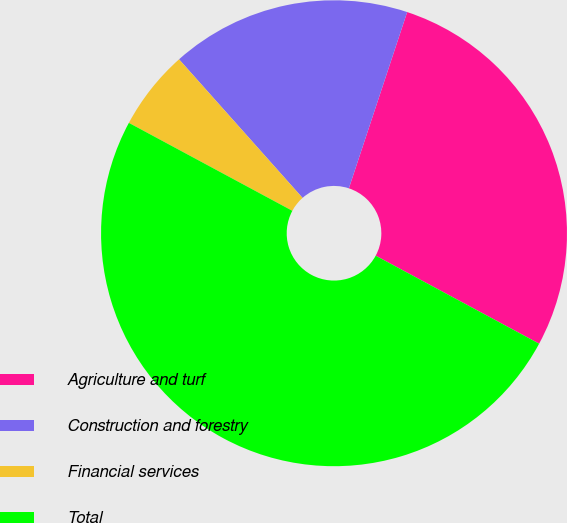Convert chart. <chart><loc_0><loc_0><loc_500><loc_500><pie_chart><fcel>Agriculture and turf<fcel>Construction and forestry<fcel>Financial services<fcel>Total<nl><fcel>27.78%<fcel>16.67%<fcel>5.56%<fcel>50.0%<nl></chart> 